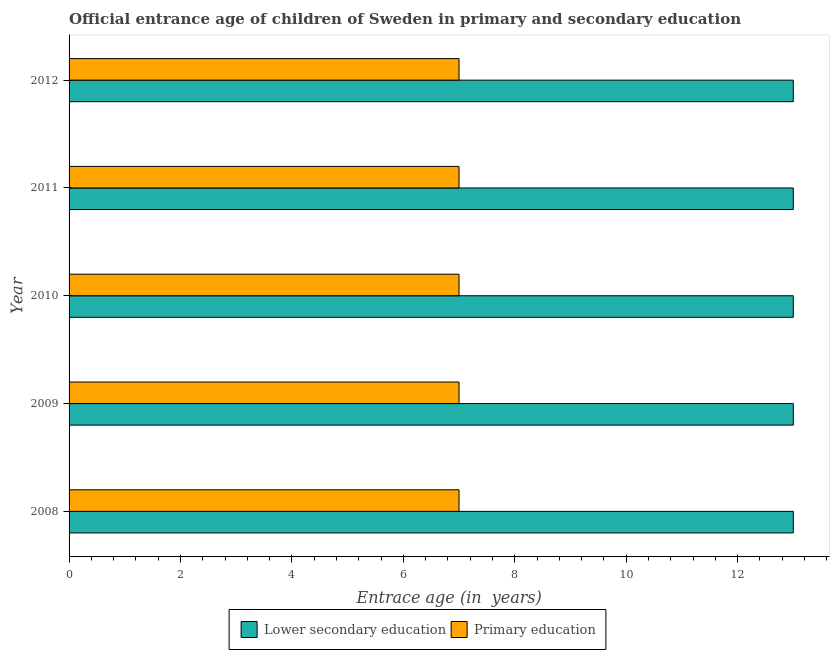How many groups of bars are there?
Provide a succinct answer. 5. Are the number of bars per tick equal to the number of legend labels?
Offer a very short reply. Yes. What is the entrance age of children in lower secondary education in 2008?
Ensure brevity in your answer.  13. Across all years, what is the maximum entrance age of children in lower secondary education?
Ensure brevity in your answer.  13. Across all years, what is the minimum entrance age of children in lower secondary education?
Ensure brevity in your answer.  13. In which year was the entrance age of chiildren in primary education maximum?
Your answer should be very brief. 2008. What is the total entrance age of children in lower secondary education in the graph?
Give a very brief answer. 65. What is the average entrance age of chiildren in primary education per year?
Offer a terse response. 7. In how many years, is the entrance age of chiildren in primary education greater than 11.2 years?
Provide a short and direct response. 0. What is the ratio of the entrance age of chiildren in primary education in 2008 to that in 2009?
Provide a succinct answer. 1. Is the entrance age of chiildren in primary education in 2009 less than that in 2010?
Your answer should be compact. No. Is the difference between the entrance age of children in lower secondary education in 2008 and 2011 greater than the difference between the entrance age of chiildren in primary education in 2008 and 2011?
Provide a succinct answer. No. What is the difference between the highest and the second highest entrance age of children in lower secondary education?
Offer a terse response. 0. Is the sum of the entrance age of children in lower secondary education in 2010 and 2012 greater than the maximum entrance age of chiildren in primary education across all years?
Your response must be concise. Yes. What does the 2nd bar from the top in 2009 represents?
Provide a succinct answer. Lower secondary education. What does the 1st bar from the bottom in 2010 represents?
Ensure brevity in your answer.  Lower secondary education. Are all the bars in the graph horizontal?
Ensure brevity in your answer.  Yes. What is the difference between two consecutive major ticks on the X-axis?
Offer a terse response. 2. Does the graph contain any zero values?
Your answer should be very brief. No. Where does the legend appear in the graph?
Your answer should be compact. Bottom center. How many legend labels are there?
Provide a succinct answer. 2. How are the legend labels stacked?
Offer a terse response. Horizontal. What is the title of the graph?
Your response must be concise. Official entrance age of children of Sweden in primary and secondary education. What is the label or title of the X-axis?
Keep it short and to the point. Entrace age (in  years). What is the label or title of the Y-axis?
Give a very brief answer. Year. What is the Entrace age (in  years) of Primary education in 2008?
Provide a short and direct response. 7. What is the Entrace age (in  years) of Lower secondary education in 2009?
Give a very brief answer. 13. What is the Entrace age (in  years) in Primary education in 2009?
Your answer should be compact. 7. What is the Entrace age (in  years) of Lower secondary education in 2010?
Your answer should be very brief. 13. What is the Entrace age (in  years) in Primary education in 2011?
Ensure brevity in your answer.  7. What is the Entrace age (in  years) of Lower secondary education in 2012?
Keep it short and to the point. 13. Across all years, what is the maximum Entrace age (in  years) in Lower secondary education?
Provide a short and direct response. 13. Across all years, what is the minimum Entrace age (in  years) of Primary education?
Give a very brief answer. 7. What is the total Entrace age (in  years) of Lower secondary education in the graph?
Offer a very short reply. 65. What is the difference between the Entrace age (in  years) of Lower secondary education in 2008 and that in 2010?
Provide a short and direct response. 0. What is the difference between the Entrace age (in  years) of Primary education in 2008 and that in 2010?
Keep it short and to the point. 0. What is the difference between the Entrace age (in  years) of Lower secondary education in 2008 and that in 2011?
Your answer should be compact. 0. What is the difference between the Entrace age (in  years) of Primary education in 2009 and that in 2010?
Provide a short and direct response. 0. What is the difference between the Entrace age (in  years) of Primary education in 2009 and that in 2011?
Give a very brief answer. 0. What is the difference between the Entrace age (in  years) in Primary education in 2010 and that in 2011?
Ensure brevity in your answer.  0. What is the difference between the Entrace age (in  years) in Lower secondary education in 2010 and that in 2012?
Your answer should be compact. 0. What is the difference between the Entrace age (in  years) in Lower secondary education in 2008 and the Entrace age (in  years) in Primary education in 2010?
Offer a very short reply. 6. What is the difference between the Entrace age (in  years) of Lower secondary education in 2008 and the Entrace age (in  years) of Primary education in 2011?
Give a very brief answer. 6. What is the difference between the Entrace age (in  years) in Lower secondary education in 2011 and the Entrace age (in  years) in Primary education in 2012?
Provide a short and direct response. 6. In the year 2008, what is the difference between the Entrace age (in  years) in Lower secondary education and Entrace age (in  years) in Primary education?
Ensure brevity in your answer.  6. What is the ratio of the Entrace age (in  years) in Primary education in 2008 to that in 2009?
Keep it short and to the point. 1. What is the ratio of the Entrace age (in  years) of Lower secondary education in 2008 to that in 2010?
Keep it short and to the point. 1. What is the ratio of the Entrace age (in  years) of Lower secondary education in 2008 to that in 2011?
Provide a succinct answer. 1. What is the ratio of the Entrace age (in  years) in Primary education in 2008 to that in 2011?
Give a very brief answer. 1. What is the ratio of the Entrace age (in  years) of Lower secondary education in 2008 to that in 2012?
Offer a terse response. 1. What is the ratio of the Entrace age (in  years) of Primary education in 2008 to that in 2012?
Your answer should be compact. 1. What is the ratio of the Entrace age (in  years) in Primary education in 2009 to that in 2010?
Your response must be concise. 1. What is the ratio of the Entrace age (in  years) of Primary education in 2009 to that in 2011?
Give a very brief answer. 1. What is the ratio of the Entrace age (in  years) of Lower secondary education in 2010 to that in 2011?
Ensure brevity in your answer.  1. What is the ratio of the Entrace age (in  years) in Primary education in 2010 to that in 2011?
Ensure brevity in your answer.  1. What is the ratio of the Entrace age (in  years) in Lower secondary education in 2010 to that in 2012?
Provide a short and direct response. 1. What is the ratio of the Entrace age (in  years) of Lower secondary education in 2011 to that in 2012?
Your answer should be very brief. 1. What is the difference between the highest and the second highest Entrace age (in  years) in Primary education?
Your answer should be compact. 0. What is the difference between the highest and the lowest Entrace age (in  years) in Lower secondary education?
Offer a very short reply. 0. What is the difference between the highest and the lowest Entrace age (in  years) in Primary education?
Ensure brevity in your answer.  0. 